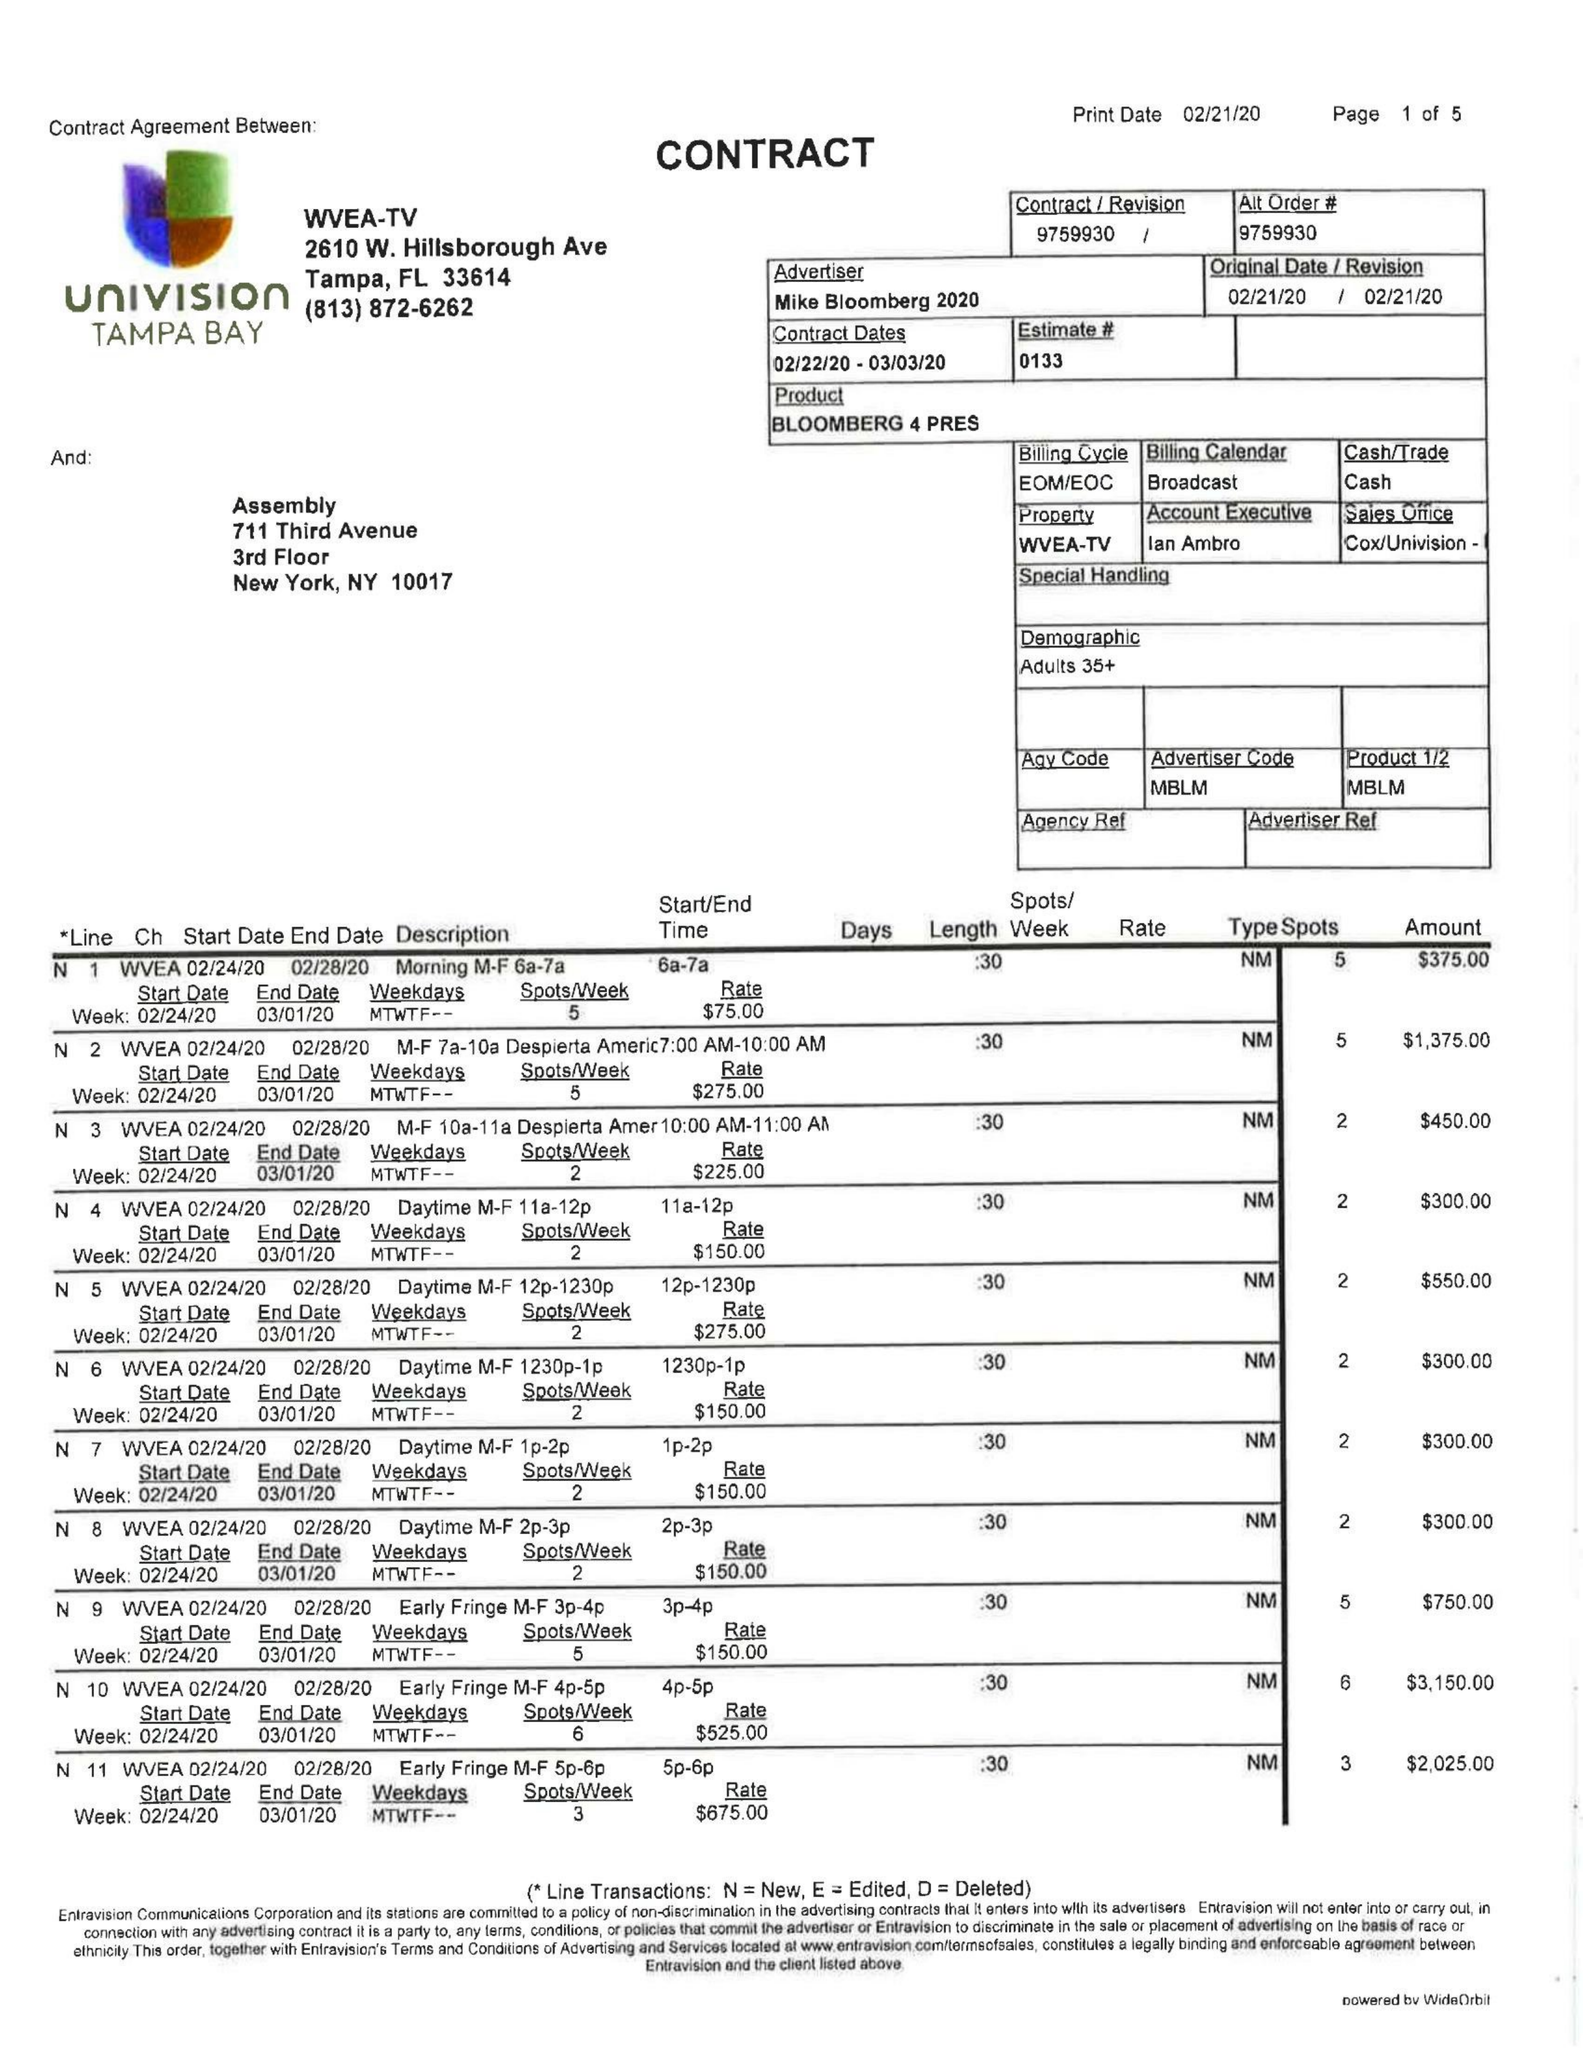What is the value for the flight_from?
Answer the question using a single word or phrase. 02/22/20 